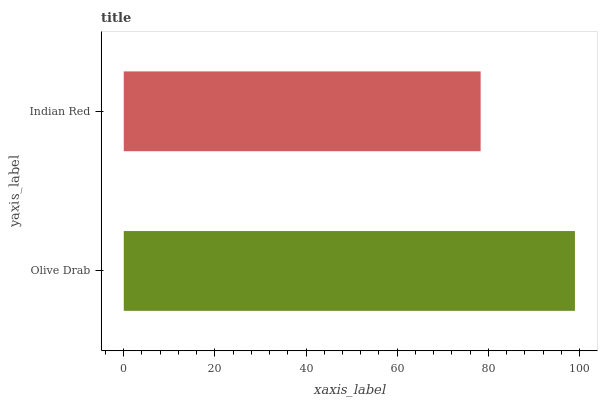Is Indian Red the minimum?
Answer yes or no. Yes. Is Olive Drab the maximum?
Answer yes or no. Yes. Is Indian Red the maximum?
Answer yes or no. No. Is Olive Drab greater than Indian Red?
Answer yes or no. Yes. Is Indian Red less than Olive Drab?
Answer yes or no. Yes. Is Indian Red greater than Olive Drab?
Answer yes or no. No. Is Olive Drab less than Indian Red?
Answer yes or no. No. Is Olive Drab the high median?
Answer yes or no. Yes. Is Indian Red the low median?
Answer yes or no. Yes. Is Indian Red the high median?
Answer yes or no. No. Is Olive Drab the low median?
Answer yes or no. No. 